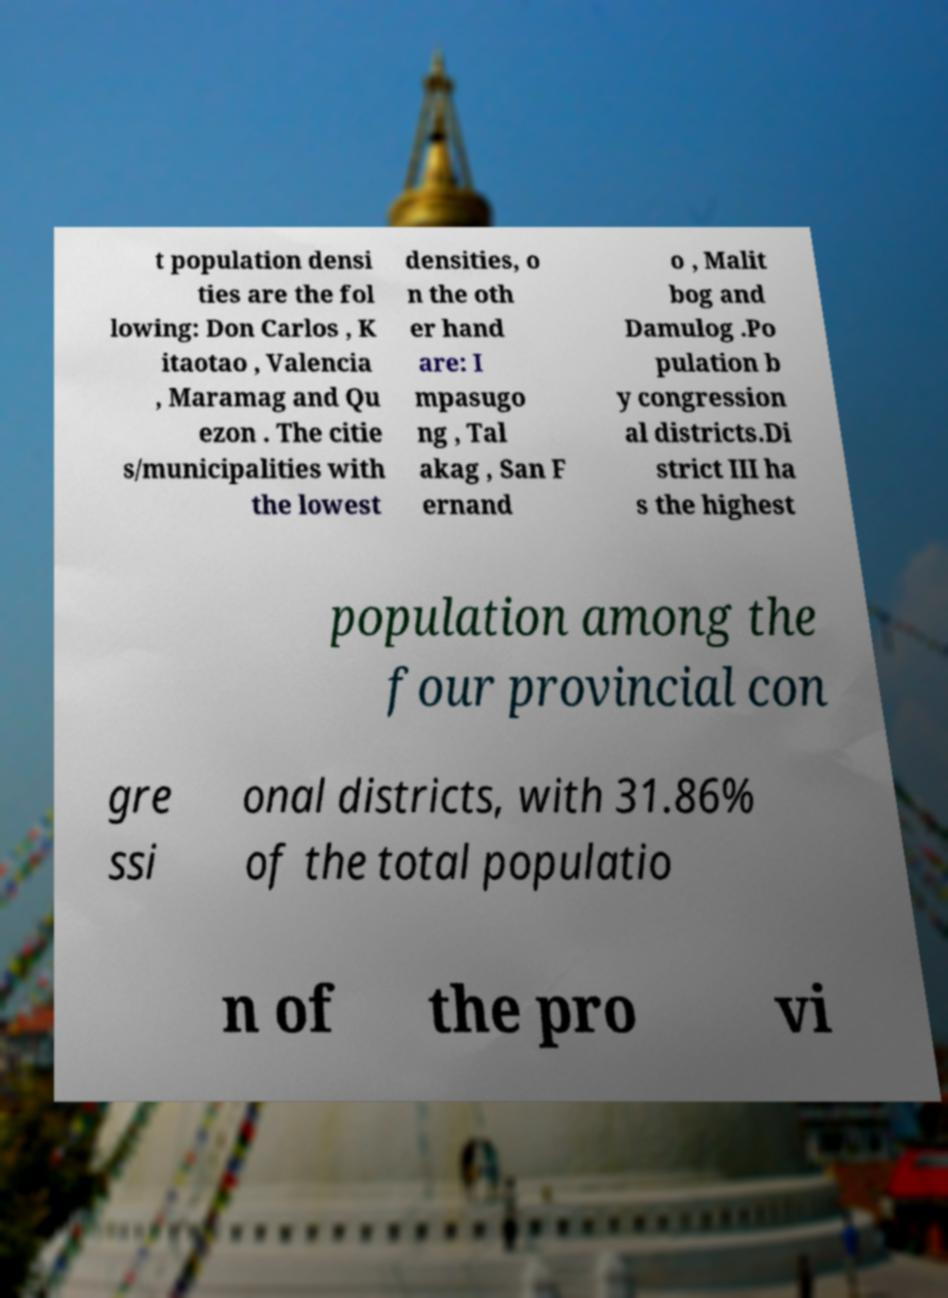Please identify and transcribe the text found in this image. t population densi ties are the fol lowing: Don Carlos , K itaotao , Valencia , Maramag and Qu ezon . The citie s/municipalities with the lowest densities, o n the oth er hand are: I mpasugo ng , Tal akag , San F ernand o , Malit bog and Damulog .Po pulation b y congression al districts.Di strict III ha s the highest population among the four provincial con gre ssi onal districts, with 31.86% of the total populatio n of the pro vi 